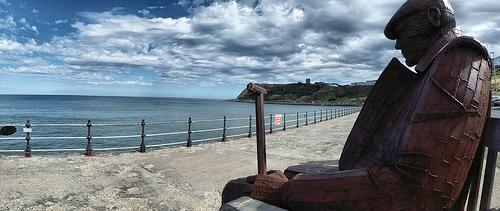How many statues are there in this picture?
Give a very brief answer. 1. 